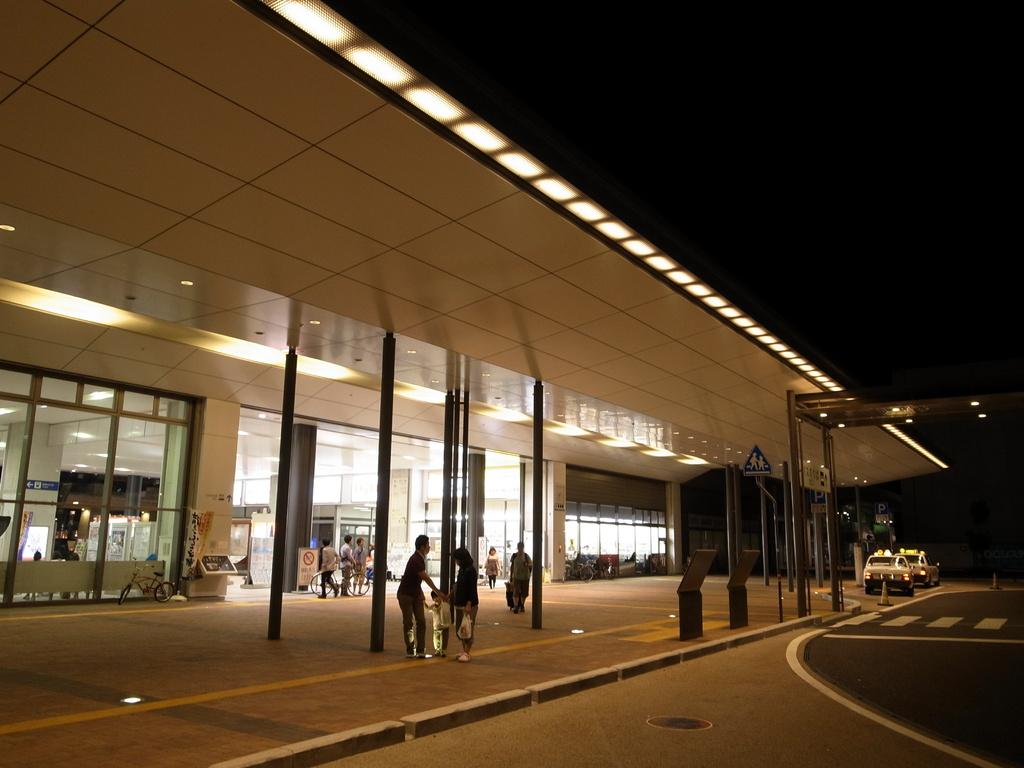How many people are present in the image? There is a group of people in the image, but the exact number cannot be determined from the provided facts. What types of vehicles can be seen in the image? There are vehicles in the image, but the specific types cannot be determined from the provided facts. What is the purpose of the lights in the image? The purpose of the lights in the image cannot be determined from the provided facts. What are the boards used for in the image? The purpose of the boards in the image cannot be determined from the provided facts. What other objects are present in the image? There are other objects in the image, but their specific nature cannot be determined from the provided facts. What type of building is visible in the image? The type of building visible in the image cannot be determined from the provided facts. How does the dog grip the board in the image? There is no dog present in the image, so it is not possible to answer that question. 